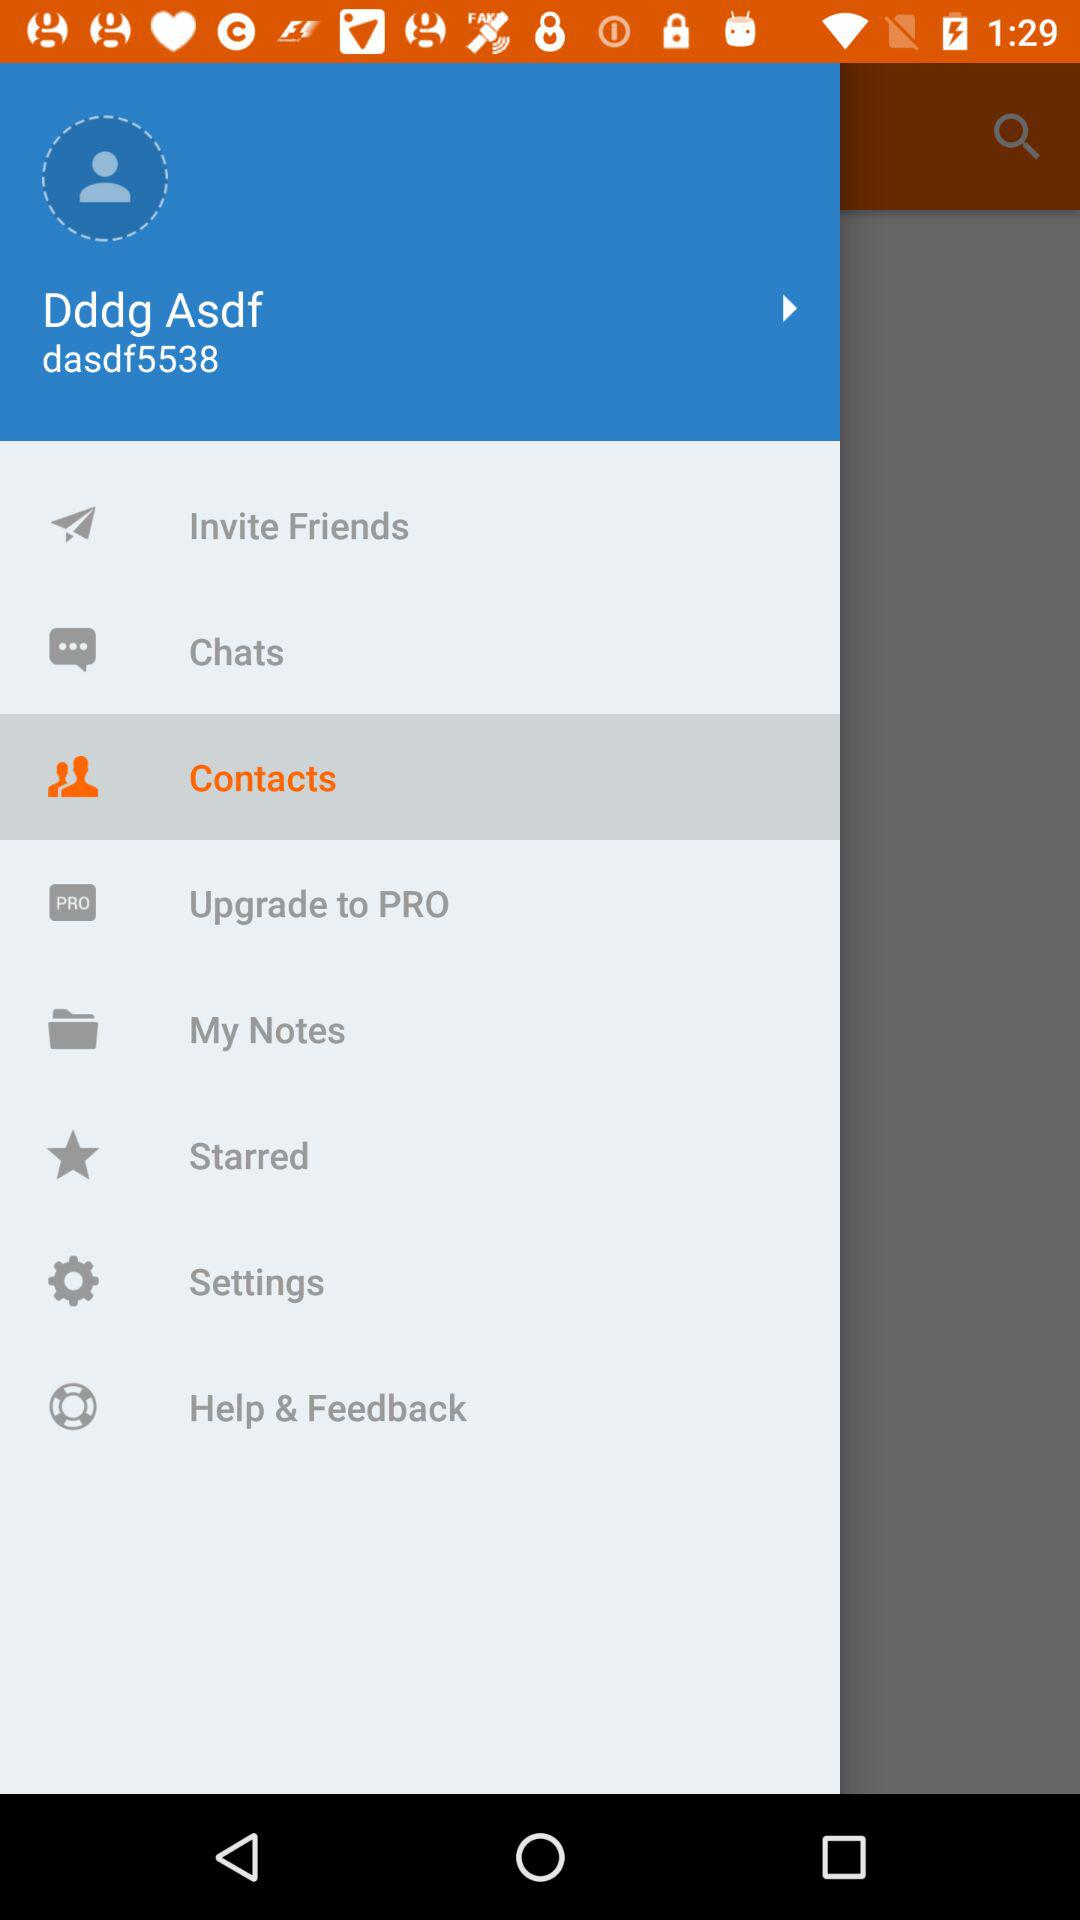Which option has been selected? The option that has been selected is "Contacts". 